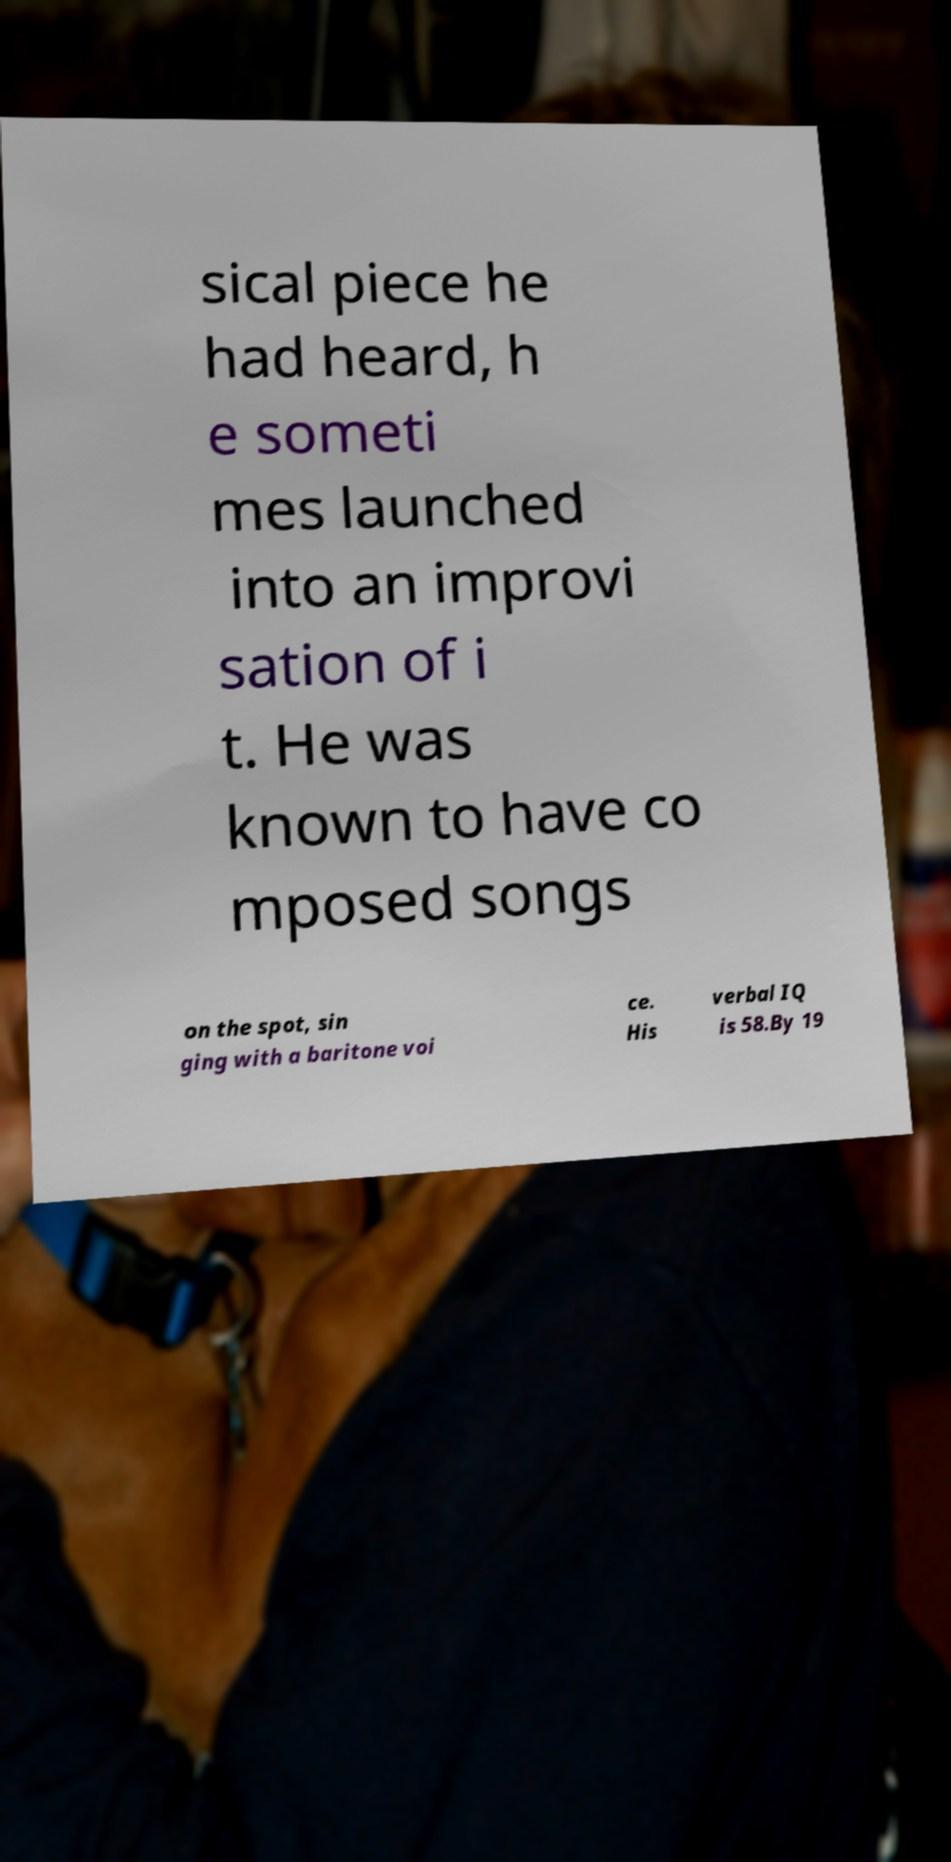Could you extract and type out the text from this image? sical piece he had heard, h e someti mes launched into an improvi sation of i t. He was known to have co mposed songs on the spot, sin ging with a baritone voi ce. His verbal IQ is 58.By 19 